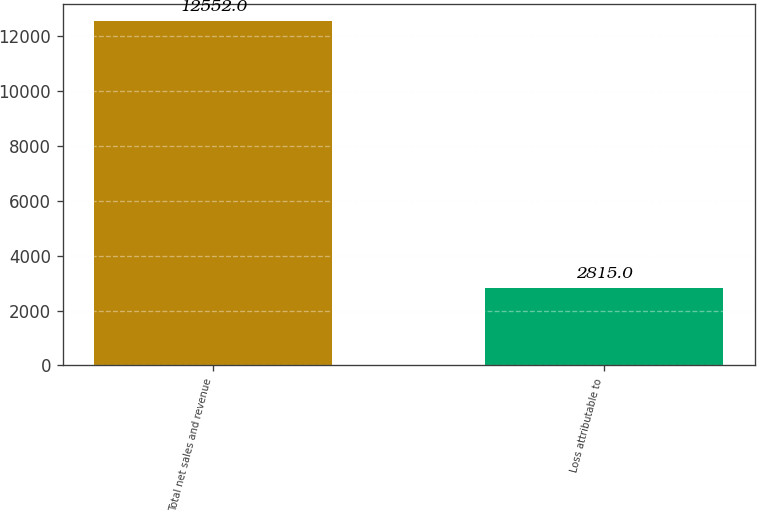Convert chart. <chart><loc_0><loc_0><loc_500><loc_500><bar_chart><fcel>Total net sales and revenue<fcel>Loss attributable to<nl><fcel>12552<fcel>2815<nl></chart> 